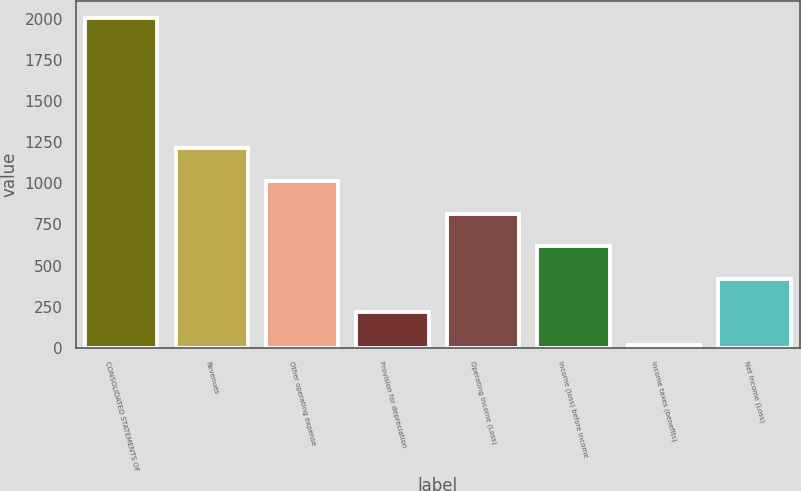Convert chart. <chart><loc_0><loc_0><loc_500><loc_500><bar_chart><fcel>CONSOLIDATED STATEMENTS OF<fcel>Revenues<fcel>Other operating expense<fcel>Provision for depreciation<fcel>Operating Income (Loss)<fcel>Income (loss) before income<fcel>Income taxes (benefits)<fcel>Net Income (Loss)<nl><fcel>2011<fcel>1213.8<fcel>1014.5<fcel>217.3<fcel>815.2<fcel>615.9<fcel>18<fcel>416.6<nl></chart> 